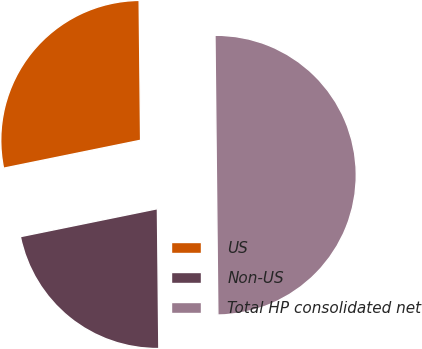Convert chart to OTSL. <chart><loc_0><loc_0><loc_500><loc_500><pie_chart><fcel>US<fcel>Non-US<fcel>Total HP consolidated net<nl><fcel>28.04%<fcel>21.96%<fcel>50.0%<nl></chart> 